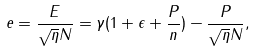Convert formula to latex. <formula><loc_0><loc_0><loc_500><loc_500>e = \frac { E } { \sqrt { \eta } N } = \gamma ( 1 + \epsilon + \frac { P } { n } ) - \frac { P } { \sqrt { \eta } N } ,</formula> 